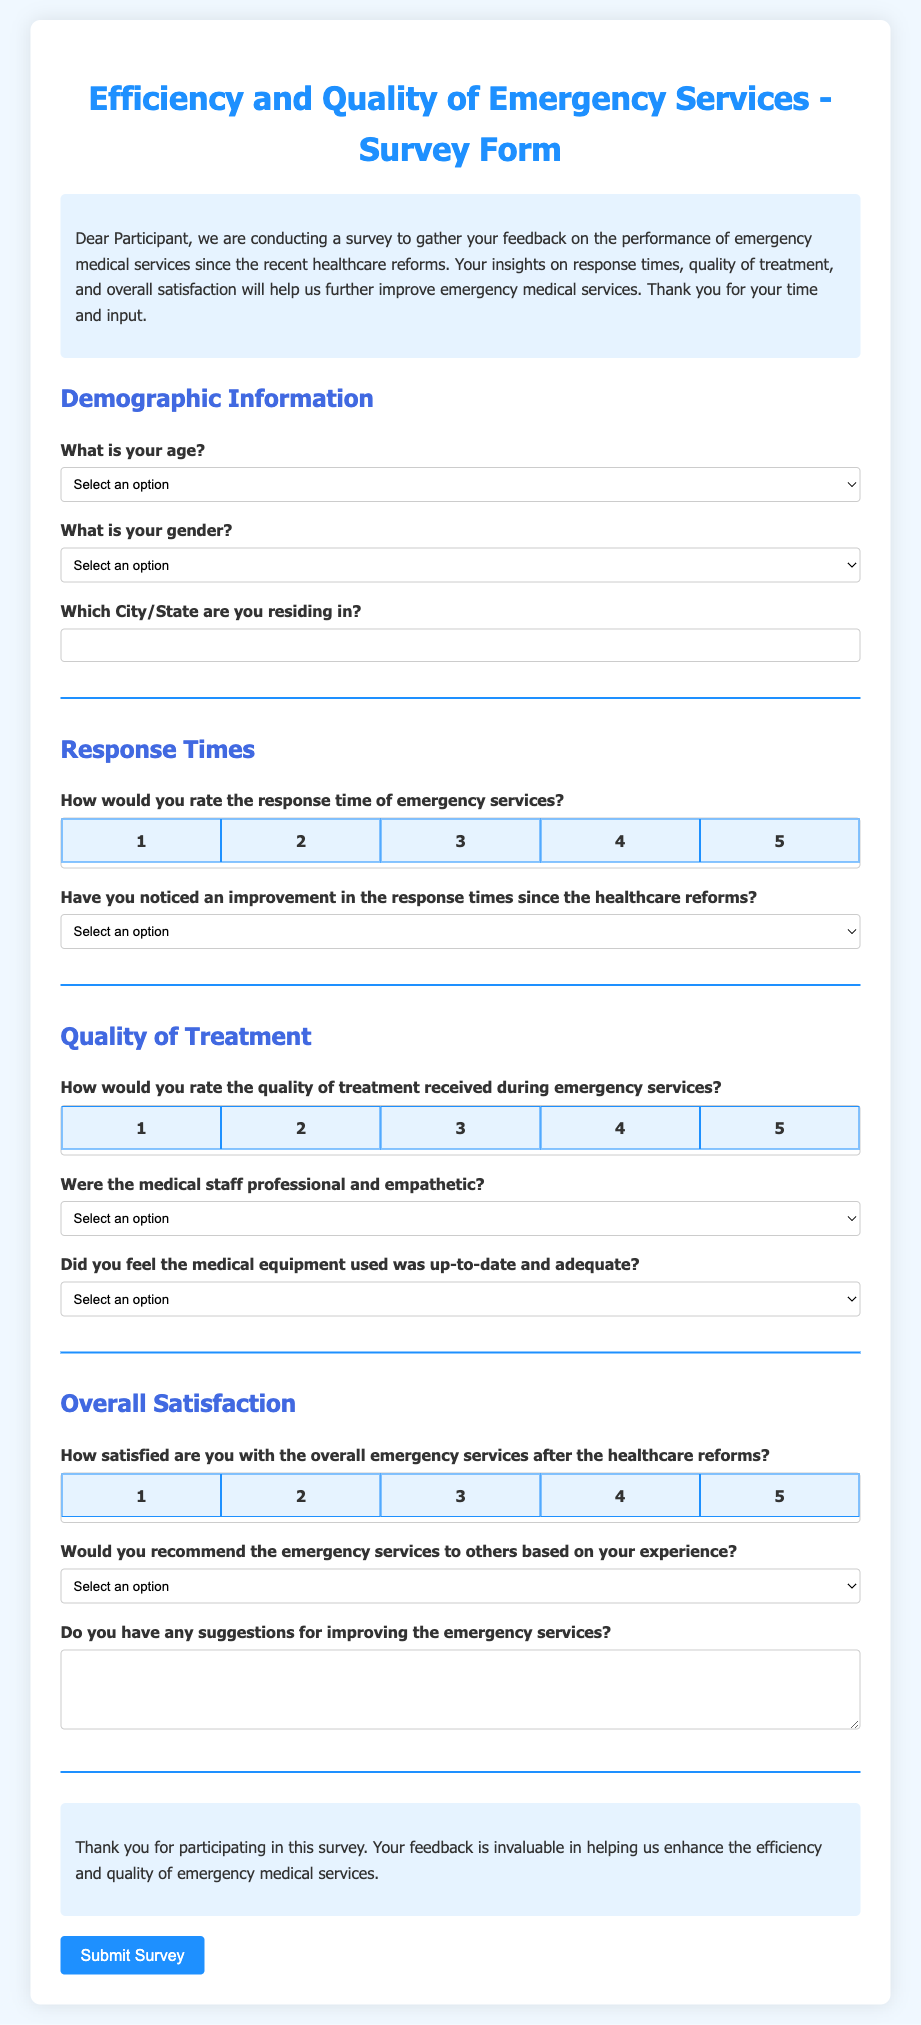What is the title of the survey form? The title is usually the prominent heading at the top of the document.
Answer: Efficiency and Quality of Emergency Services - Survey Form What is the purpose of the survey? The purpose is generally outlined in an introductory paragraph or section.
Answer: To gather feedback on the performance of emergency medical services since the healthcare reforms How many response options are provided for the question about response time? This can be determined by counting the options under the specific question section.
Answer: 5 What age group does the option "46-60" fall under in the survey? This group is listed as one of the selectable options in the demographic section.
Answer: Age group: 46-60 What selection is available for indicating if there was an improvement in response times? This information is typically framed as a question with multiple-choice answers.
Answer: Yes, No, Not Sure How is the medical staff's professionalism assessed in the survey? The professionalism is evaluated through a selected multiple-choice question under the quality of treatment section.
Answer: Strongly Agree, Agree, Neutral, Disagree, Strongly Disagree What is the rating scale used for quality of treatment? This is defined by the number of positions available in the rating section for that question.
Answer: 1 to 5 What does the closing section express? This section typically conveys gratitude or final thoughts related to survey completion.
Answer: Thank you for participating in this survey Would you need to provide suggestions for improvement in the survey? This is indicated by a separate question prompting participants for input.
Answer: Yes, there is a question for suggestions 